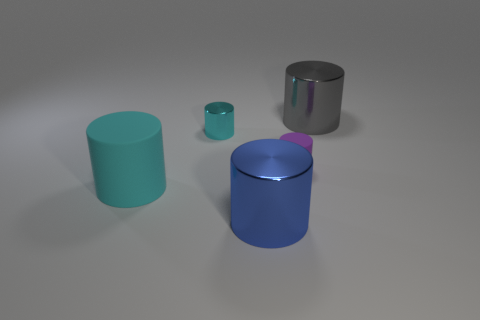There is a rubber cylinder that is on the right side of the cyan rubber cylinder; is it the same size as the rubber object that is on the left side of the large blue metallic thing?
Provide a succinct answer. No. What is the size of the cyan rubber thing that is the same shape as the large blue metal thing?
Make the answer very short. Large. There is a blue metallic object; is its size the same as the metallic object that is right of the blue object?
Keep it short and to the point. Yes. There is a large object behind the cyan rubber object; is there a big gray shiny cylinder right of it?
Ensure brevity in your answer.  No. The matte object that is in front of the small purple matte thing has what shape?
Make the answer very short. Cylinder. There is another object that is the same color as the large rubber object; what is it made of?
Provide a succinct answer. Metal. What is the color of the cylinder that is in front of the cyan cylinder that is on the left side of the tiny cyan cylinder?
Your answer should be compact. Blue. Do the purple matte cylinder and the blue metal cylinder have the same size?
Ensure brevity in your answer.  No. There is a tiny cyan object that is the same shape as the big rubber object; what is it made of?
Keep it short and to the point. Metal. What number of gray objects are the same size as the blue cylinder?
Ensure brevity in your answer.  1. 